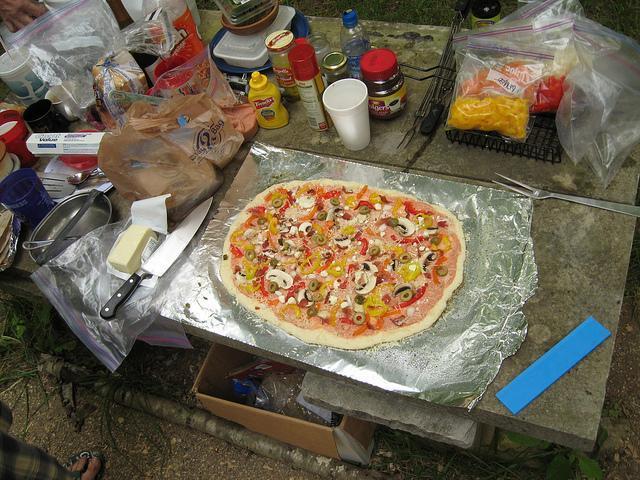How many cups are there?
Give a very brief answer. 2. How many refrigerators are in this image?
Give a very brief answer. 0. 